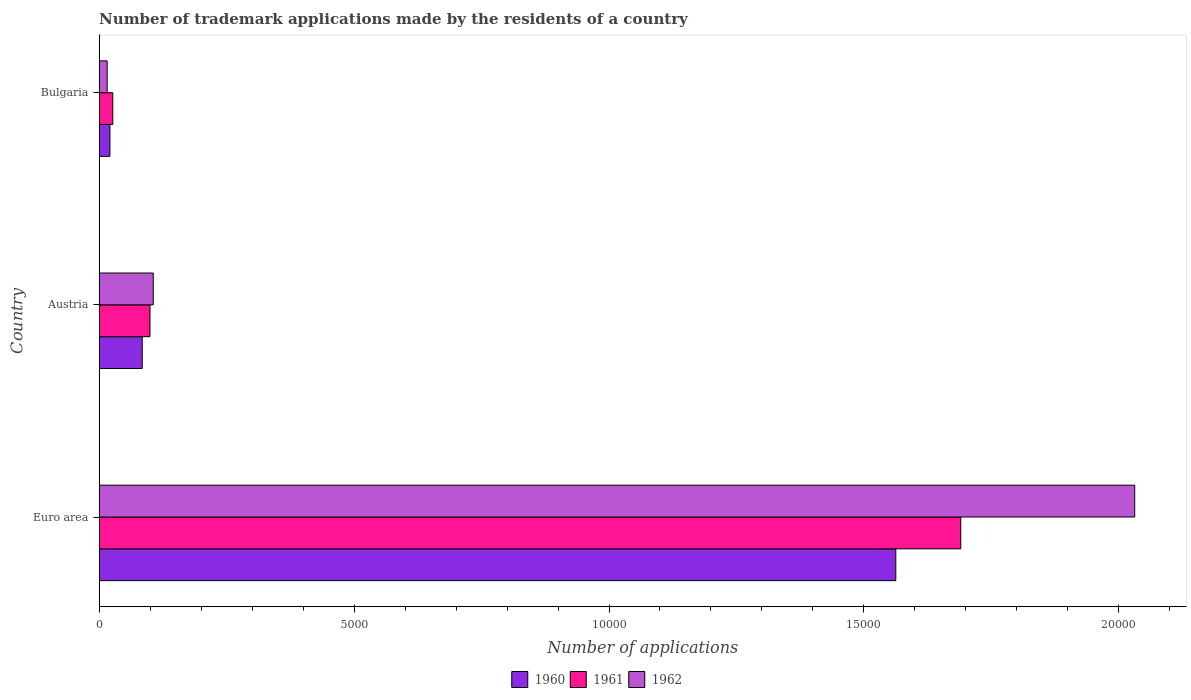How many different coloured bars are there?
Your answer should be very brief. 3. How many groups of bars are there?
Make the answer very short. 3. How many bars are there on the 3rd tick from the top?
Ensure brevity in your answer.  3. What is the label of the 2nd group of bars from the top?
Offer a very short reply. Austria. What is the number of trademark applications made by the residents in 1960 in Bulgaria?
Your answer should be compact. 211. Across all countries, what is the maximum number of trademark applications made by the residents in 1962?
Provide a succinct answer. 2.03e+04. Across all countries, what is the minimum number of trademark applications made by the residents in 1962?
Give a very brief answer. 157. What is the total number of trademark applications made by the residents in 1961 in the graph?
Offer a terse response. 1.82e+04. What is the difference between the number of trademark applications made by the residents in 1962 in Austria and that in Euro area?
Make the answer very short. -1.92e+04. What is the difference between the number of trademark applications made by the residents in 1960 in Euro area and the number of trademark applications made by the residents in 1962 in Bulgaria?
Give a very brief answer. 1.55e+04. What is the average number of trademark applications made by the residents in 1960 per country?
Offer a terse response. 5560.33. What is the difference between the number of trademark applications made by the residents in 1960 and number of trademark applications made by the residents in 1962 in Bulgaria?
Your response must be concise. 54. What is the ratio of the number of trademark applications made by the residents in 1962 in Austria to that in Bulgaria?
Give a very brief answer. 6.76. Is the difference between the number of trademark applications made by the residents in 1960 in Austria and Euro area greater than the difference between the number of trademark applications made by the residents in 1962 in Austria and Euro area?
Your response must be concise. Yes. What is the difference between the highest and the second highest number of trademark applications made by the residents in 1962?
Offer a terse response. 1.92e+04. What is the difference between the highest and the lowest number of trademark applications made by the residents in 1960?
Your answer should be very brief. 1.54e+04. Is the sum of the number of trademark applications made by the residents in 1960 in Bulgaria and Euro area greater than the maximum number of trademark applications made by the residents in 1961 across all countries?
Keep it short and to the point. No. What does the 1st bar from the bottom in Euro area represents?
Provide a short and direct response. 1960. Is it the case that in every country, the sum of the number of trademark applications made by the residents in 1961 and number of trademark applications made by the residents in 1960 is greater than the number of trademark applications made by the residents in 1962?
Offer a terse response. Yes. How many bars are there?
Provide a succinct answer. 9. How many countries are there in the graph?
Your answer should be compact. 3. Does the graph contain any zero values?
Your answer should be compact. No. How are the legend labels stacked?
Provide a succinct answer. Horizontal. What is the title of the graph?
Provide a succinct answer. Number of trademark applications made by the residents of a country. Does "2011" appear as one of the legend labels in the graph?
Provide a short and direct response. No. What is the label or title of the X-axis?
Your response must be concise. Number of applications. What is the Number of applications in 1960 in Euro area?
Provide a short and direct response. 1.56e+04. What is the Number of applications in 1961 in Euro area?
Your answer should be very brief. 1.69e+04. What is the Number of applications in 1962 in Euro area?
Your answer should be very brief. 2.03e+04. What is the Number of applications in 1960 in Austria?
Your answer should be compact. 845. What is the Number of applications of 1961 in Austria?
Ensure brevity in your answer.  997. What is the Number of applications of 1962 in Austria?
Ensure brevity in your answer.  1061. What is the Number of applications of 1960 in Bulgaria?
Your response must be concise. 211. What is the Number of applications in 1961 in Bulgaria?
Offer a very short reply. 267. What is the Number of applications in 1962 in Bulgaria?
Ensure brevity in your answer.  157. Across all countries, what is the maximum Number of applications in 1960?
Your response must be concise. 1.56e+04. Across all countries, what is the maximum Number of applications of 1961?
Your answer should be very brief. 1.69e+04. Across all countries, what is the maximum Number of applications in 1962?
Provide a short and direct response. 2.03e+04. Across all countries, what is the minimum Number of applications in 1960?
Your answer should be very brief. 211. Across all countries, what is the minimum Number of applications in 1961?
Offer a very short reply. 267. Across all countries, what is the minimum Number of applications in 1962?
Your answer should be very brief. 157. What is the total Number of applications in 1960 in the graph?
Ensure brevity in your answer.  1.67e+04. What is the total Number of applications in 1961 in the graph?
Give a very brief answer. 1.82e+04. What is the total Number of applications of 1962 in the graph?
Your answer should be very brief. 2.15e+04. What is the difference between the Number of applications of 1960 in Euro area and that in Austria?
Provide a short and direct response. 1.48e+04. What is the difference between the Number of applications in 1961 in Euro area and that in Austria?
Make the answer very short. 1.59e+04. What is the difference between the Number of applications of 1962 in Euro area and that in Austria?
Your answer should be compact. 1.92e+04. What is the difference between the Number of applications in 1960 in Euro area and that in Bulgaria?
Give a very brief answer. 1.54e+04. What is the difference between the Number of applications in 1961 in Euro area and that in Bulgaria?
Make the answer very short. 1.66e+04. What is the difference between the Number of applications of 1962 in Euro area and that in Bulgaria?
Provide a short and direct response. 2.02e+04. What is the difference between the Number of applications in 1960 in Austria and that in Bulgaria?
Give a very brief answer. 634. What is the difference between the Number of applications of 1961 in Austria and that in Bulgaria?
Keep it short and to the point. 730. What is the difference between the Number of applications in 1962 in Austria and that in Bulgaria?
Provide a short and direct response. 904. What is the difference between the Number of applications in 1960 in Euro area and the Number of applications in 1961 in Austria?
Your answer should be very brief. 1.46e+04. What is the difference between the Number of applications of 1960 in Euro area and the Number of applications of 1962 in Austria?
Provide a short and direct response. 1.46e+04. What is the difference between the Number of applications of 1961 in Euro area and the Number of applications of 1962 in Austria?
Your answer should be very brief. 1.58e+04. What is the difference between the Number of applications in 1960 in Euro area and the Number of applications in 1961 in Bulgaria?
Provide a short and direct response. 1.54e+04. What is the difference between the Number of applications of 1960 in Euro area and the Number of applications of 1962 in Bulgaria?
Offer a very short reply. 1.55e+04. What is the difference between the Number of applications in 1961 in Euro area and the Number of applications in 1962 in Bulgaria?
Offer a terse response. 1.67e+04. What is the difference between the Number of applications of 1960 in Austria and the Number of applications of 1961 in Bulgaria?
Your answer should be very brief. 578. What is the difference between the Number of applications in 1960 in Austria and the Number of applications in 1962 in Bulgaria?
Your response must be concise. 688. What is the difference between the Number of applications in 1961 in Austria and the Number of applications in 1962 in Bulgaria?
Provide a succinct answer. 840. What is the average Number of applications in 1960 per country?
Offer a very short reply. 5560.33. What is the average Number of applications of 1961 per country?
Make the answer very short. 6054.33. What is the average Number of applications in 1962 per country?
Your answer should be very brief. 7176.33. What is the difference between the Number of applications of 1960 and Number of applications of 1961 in Euro area?
Make the answer very short. -1274. What is the difference between the Number of applications of 1960 and Number of applications of 1962 in Euro area?
Provide a succinct answer. -4686. What is the difference between the Number of applications in 1961 and Number of applications in 1962 in Euro area?
Provide a short and direct response. -3412. What is the difference between the Number of applications of 1960 and Number of applications of 1961 in Austria?
Provide a short and direct response. -152. What is the difference between the Number of applications of 1960 and Number of applications of 1962 in Austria?
Offer a terse response. -216. What is the difference between the Number of applications of 1961 and Number of applications of 1962 in Austria?
Offer a very short reply. -64. What is the difference between the Number of applications in 1960 and Number of applications in 1961 in Bulgaria?
Offer a very short reply. -56. What is the difference between the Number of applications of 1960 and Number of applications of 1962 in Bulgaria?
Provide a short and direct response. 54. What is the difference between the Number of applications in 1961 and Number of applications in 1962 in Bulgaria?
Keep it short and to the point. 110. What is the ratio of the Number of applications of 1960 in Euro area to that in Austria?
Your answer should be very brief. 18.49. What is the ratio of the Number of applications of 1961 in Euro area to that in Austria?
Provide a short and direct response. 16.95. What is the ratio of the Number of applications of 1962 in Euro area to that in Austria?
Keep it short and to the point. 19.14. What is the ratio of the Number of applications in 1960 in Euro area to that in Bulgaria?
Your answer should be compact. 74.05. What is the ratio of the Number of applications of 1961 in Euro area to that in Bulgaria?
Your answer should be very brief. 63.29. What is the ratio of the Number of applications in 1962 in Euro area to that in Bulgaria?
Make the answer very short. 129.37. What is the ratio of the Number of applications of 1960 in Austria to that in Bulgaria?
Provide a succinct answer. 4. What is the ratio of the Number of applications of 1961 in Austria to that in Bulgaria?
Provide a succinct answer. 3.73. What is the ratio of the Number of applications of 1962 in Austria to that in Bulgaria?
Provide a succinct answer. 6.76. What is the difference between the highest and the second highest Number of applications in 1960?
Provide a short and direct response. 1.48e+04. What is the difference between the highest and the second highest Number of applications in 1961?
Give a very brief answer. 1.59e+04. What is the difference between the highest and the second highest Number of applications of 1962?
Make the answer very short. 1.92e+04. What is the difference between the highest and the lowest Number of applications of 1960?
Your response must be concise. 1.54e+04. What is the difference between the highest and the lowest Number of applications in 1961?
Your answer should be compact. 1.66e+04. What is the difference between the highest and the lowest Number of applications of 1962?
Give a very brief answer. 2.02e+04. 